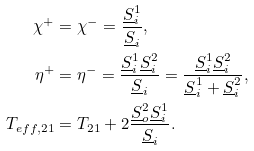Convert formula to latex. <formula><loc_0><loc_0><loc_500><loc_500>\chi ^ { + } & = \chi ^ { - } = \frac { \underline { S } _ { i } ^ { 1 } } { \underline { S } _ { i } } , \\ \eta ^ { + } & = \eta ^ { - } = \frac { \underline { S } _ { i } ^ { 1 } \underline { S } _ { i } ^ { 2 } } { \underline { S } _ { i } } = \frac { \underline { S } _ { i } ^ { 1 } \underline { S } _ { i } ^ { 2 } } { \underline { S } _ { i } ^ { 1 } + \underline { S } _ { i } ^ { 2 } } , \\ T _ { e f f , 2 1 } & = T _ { 2 1 } + 2 \frac { \underline { S } _ { o } ^ { 2 } \underline { S } _ { i } ^ { 1 } } { \underline { S } _ { i } } .</formula> 